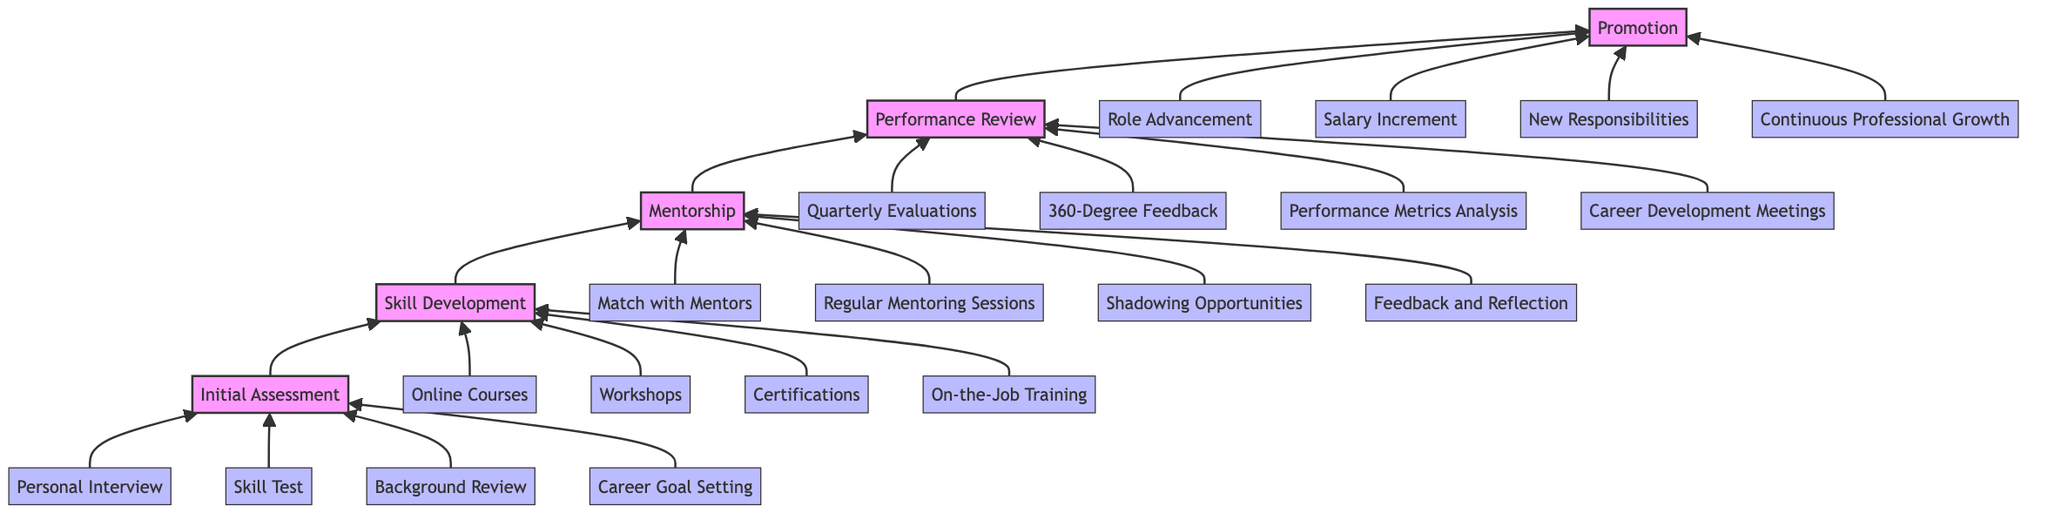What is the first stage in the pathway? The first stage in the pathway, as indicated at the bottom of the diagram, is "Initial Assessment."
Answer: Initial Assessment How many components are there in the Skill Development stage? The Skill Development stage contains four components: Online Courses, Workshops, Certifications, and On-the-Job Training.
Answer: 4 Which stage directly follows Mentorship? Following the Mentorship stage, the next stage in the upward flow is Performance Review.
Answer: Performance Review What is the fourth component of the Performance Review? The fourth component of the Performance Review stage, as listed, is "Career Development Meetings."
Answer: Career Development Meetings How many total stages are represented in this diagram? There are five distinct stages represented in the diagram: Initial Assessment, Skill Development, Mentorship, Performance Review, and Promotion.
Answer: 5 What type of training is included in the Skill Development stage? The types of training included in the Skill Development stage are Online Courses, Workshops, Certifications, and On-the-Job Training.
Answer: All listed types of training Which stage's description mentions guiding employees? The stage that mentions guiding employees in its description is Mentorship.
Answer: Mentorship What happens after Performance Review? After the Performance Review stage, employees advance to the Promotion stage.
Answer: Promotion How many total components are there across all stages? There are 20 total components when you add the components from each of the five stages in the diagram.
Answer: 20 What is the primary purpose of the Initial Assessment stage? The primary purpose of the Initial Assessment stage is to evaluate and understand an employee's current skills and potential areas for improvement.
Answer: Evaluate skills and improvement areas 